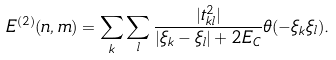Convert formula to latex. <formula><loc_0><loc_0><loc_500><loc_500>E ^ { ( 2 ) } ( n , m ) = \sum _ { k } \sum _ { l } \frac { | t _ { k l } ^ { 2 } | } { | \xi _ { k } - \xi _ { l } | + 2 E _ { C } } \theta ( - \xi _ { k } \xi _ { l } ) .</formula> 